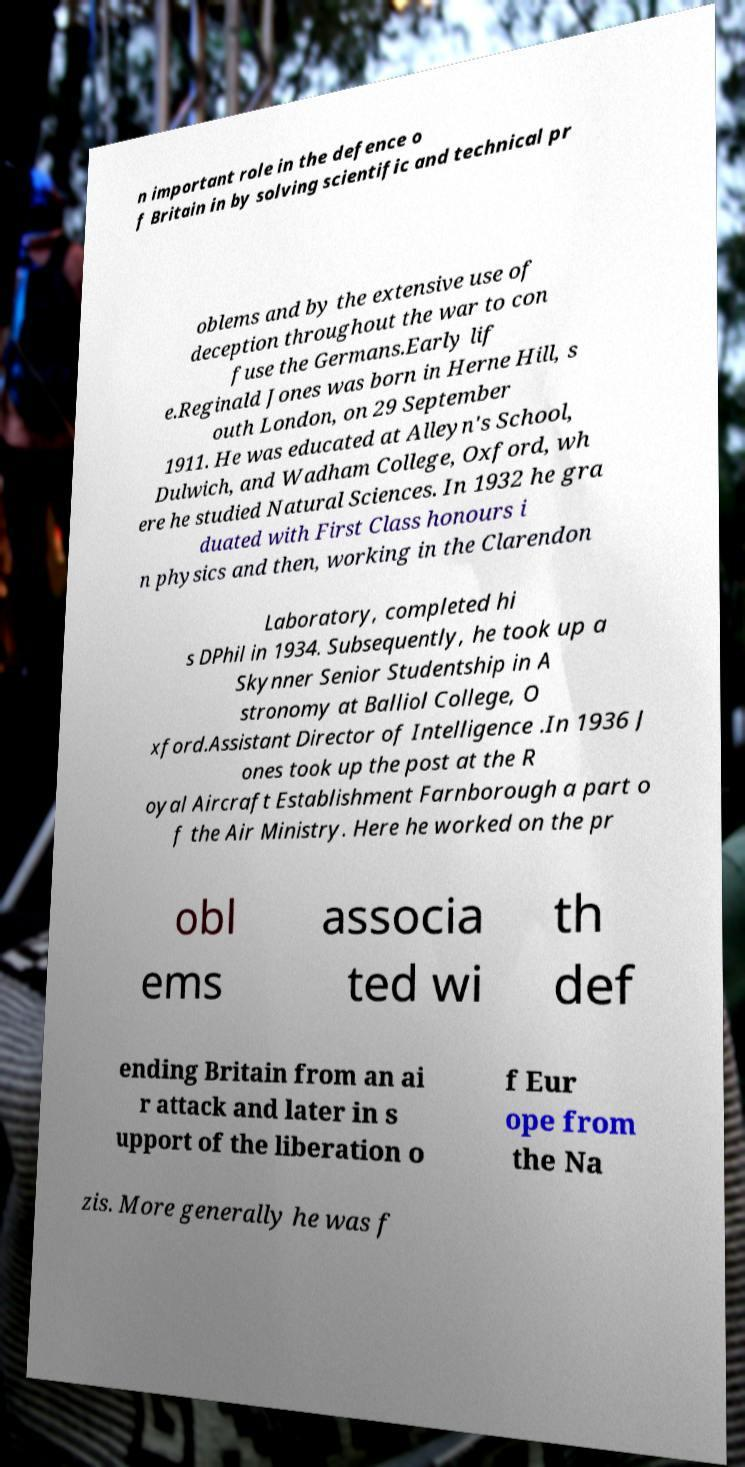Can you accurately transcribe the text from the provided image for me? n important role in the defence o f Britain in by solving scientific and technical pr oblems and by the extensive use of deception throughout the war to con fuse the Germans.Early lif e.Reginald Jones was born in Herne Hill, s outh London, on 29 September 1911. He was educated at Alleyn's School, Dulwich, and Wadham College, Oxford, wh ere he studied Natural Sciences. In 1932 he gra duated with First Class honours i n physics and then, working in the Clarendon Laboratory, completed hi s DPhil in 1934. Subsequently, he took up a Skynner Senior Studentship in A stronomy at Balliol College, O xford.Assistant Director of Intelligence .In 1936 J ones took up the post at the R oyal Aircraft Establishment Farnborough a part o f the Air Ministry. Here he worked on the pr obl ems associa ted wi th def ending Britain from an ai r attack and later in s upport of the liberation o f Eur ope from the Na zis. More generally he was f 